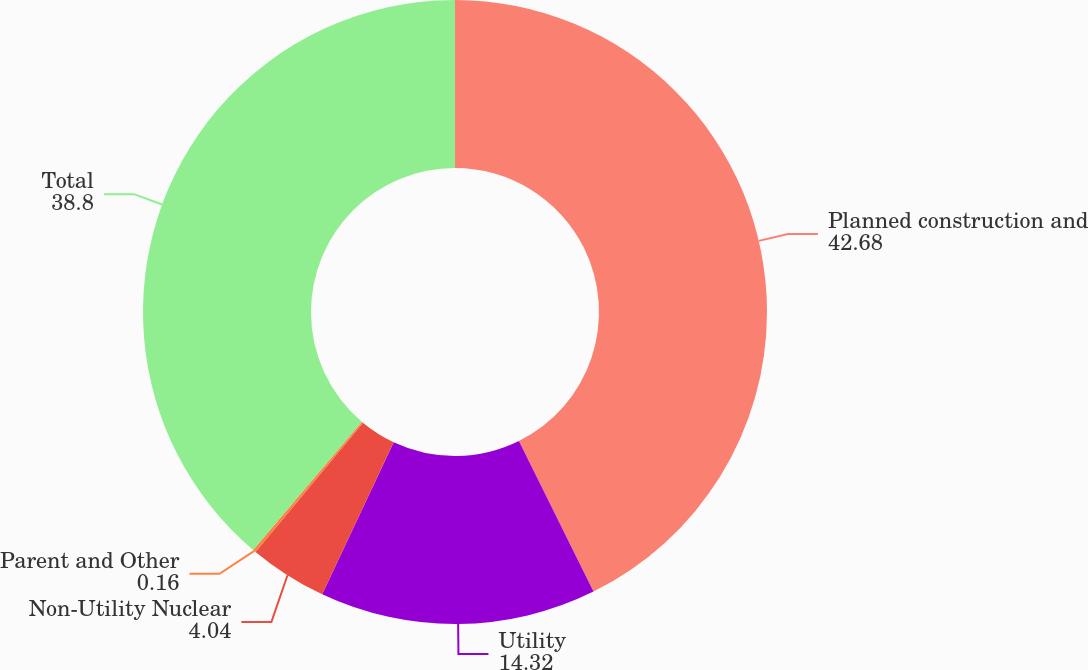Convert chart to OTSL. <chart><loc_0><loc_0><loc_500><loc_500><pie_chart><fcel>Planned construction and<fcel>Utility<fcel>Non-Utility Nuclear<fcel>Parent and Other<fcel>Total<nl><fcel>42.68%<fcel>14.32%<fcel>4.04%<fcel>0.16%<fcel>38.8%<nl></chart> 